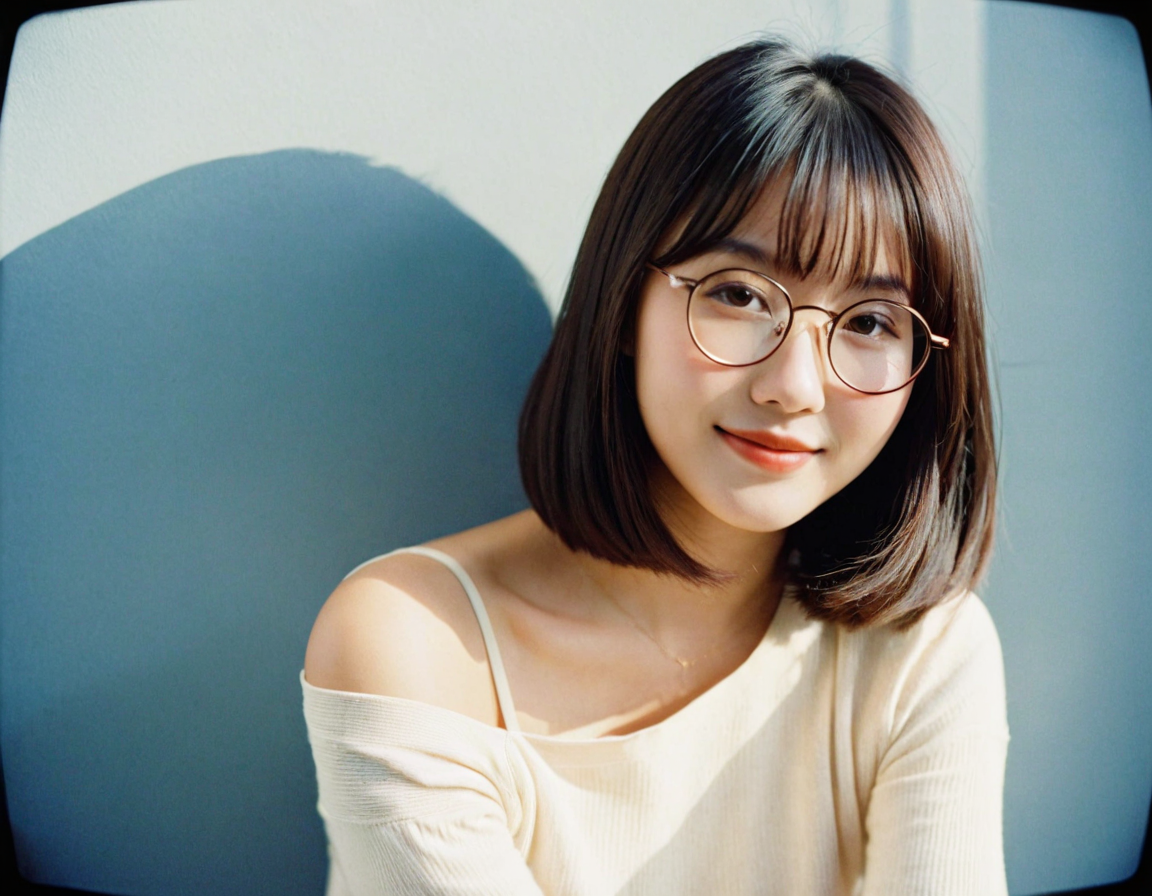This photo depicts a young ordinary woman, aged 21. Write a three paragraph introductory article for the woman in this photo, in the first person perspective of the woman herself. The article starts with a paragraph introducing herself and offering some basic information about her. The second paragraph should have her go through her appearances as seen in the photo. The final paragraph should have her sharing her hobbies and interests and end with a call to action asking her audience to share their interests with her. You may think of all the other information about the woman, such as her name and her occupation and her interests yourself. Hello there! I'm Emily, a fresh-faced 21-year-old with a passion for graphic design and a penchant for bringing color and creativity into everything I do. Born and raised in the bustling heart of the city, I find joy in the little things: the hum of the urban landscape, the vibrant street art adorning the alleyways, and the eclectic mix of people that make up the tapestry of my life. I'm currently in my final year at university, majoring in Visual Arts, and I'm excited about the endless possibilities that lie ahead.

In this photo, you can see me sporting a pair of round, rose-gold glasses that I absolutely adore – they're my signature accessory and help frame my expressive eyes, which I like to think reflect my lively spirit. My hair is a dark chestnut, cut in a chic bob that grazes my shoulders and complements my easygoing yet stylish aesthetic. I'm dressed in a soft, off-shoulder cream sweater that adds a touch of elegance while keeping things cozy and approachable, just how I like to present myself.

When I'm not buried in my sketchbooks or tweaking designs on my laptop, you can find me exploring new cafes, camera in hand, as I'm an avid coffee lover and budding photographer. I also enjoy winding down with a good book or getting lost in the melodies of indie music. My ultimate weekend is spent with friends, trying out new DIY projects or simply sharing stories and laughter. I'd love to connect with fellow creatives and hear about your hobbies and interests. So, dive into the comments, and let's share the quirks and passions that make us unique! 